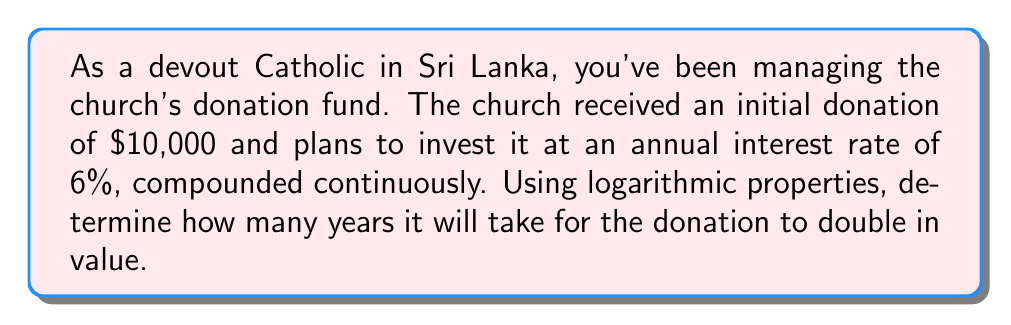Can you solve this math problem? Let's approach this step-by-step using the continuous compound interest formula and logarithmic properties:

1) The formula for continuous compound interest is:
   
   $$A = P e^{rt}$$

   Where:
   $A$ = final amount
   $P$ = principal (initial amount)
   $e$ = Euler's number (approximately 2.71828)
   $r$ = annual interest rate (as a decimal)
   $t$ = time in years

2) We want to find when the amount doubles, so:
   
   $$2P = P e^{rt}$$

3) Divide both sides by $P$:
   
   $$2 = e^{rt}$$

4) Take the natural logarithm of both sides:
   
   $$\ln(2) = \ln(e^{rt})$$

5) Using the logarithmic property $\ln(e^x) = x$:
   
   $$\ln(2) = rt$$

6) Solve for $t$:
   
   $$t = \frac{\ln(2)}{r}$$

7) Substitute the given interest rate $r = 0.06$:
   
   $$t = \frac{\ln(2)}{0.06}$$

8) Calculate:
   
   $$t \approx 11.55 \text{ years}$$
Answer: It will take approximately 11.55 years for the church's donation to double in value. 